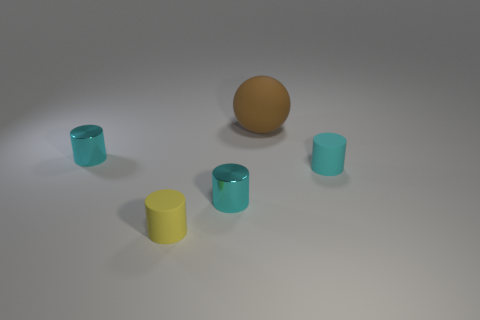Is there anything else that has the same color as the sphere?
Provide a short and direct response. No. Are there fewer large brown matte balls that are right of the small cyan matte cylinder than tiny gray metallic cylinders?
Your response must be concise. No. How many brown objects are the same size as the sphere?
Make the answer very short. 0. What is the shape of the rubber object that is in front of the tiny metal cylinder on the right side of the metallic cylinder behind the small cyan matte cylinder?
Your answer should be very brief. Cylinder. What is the color of the matte cylinder that is in front of the cyan rubber thing?
Your answer should be very brief. Yellow. How many things are either small rubber objects right of the small yellow thing or objects on the right side of the large brown matte sphere?
Your answer should be compact. 1. What number of other small yellow objects are the same shape as the tiny yellow thing?
Provide a short and direct response. 0. There is a matte object that is the same size as the yellow rubber cylinder; what is its color?
Your answer should be compact. Cyan. The matte object that is behind the small object that is behind the cyan object on the right side of the ball is what color?
Offer a terse response. Brown. Does the yellow cylinder have the same size as the brown thing behind the yellow cylinder?
Keep it short and to the point. No. 